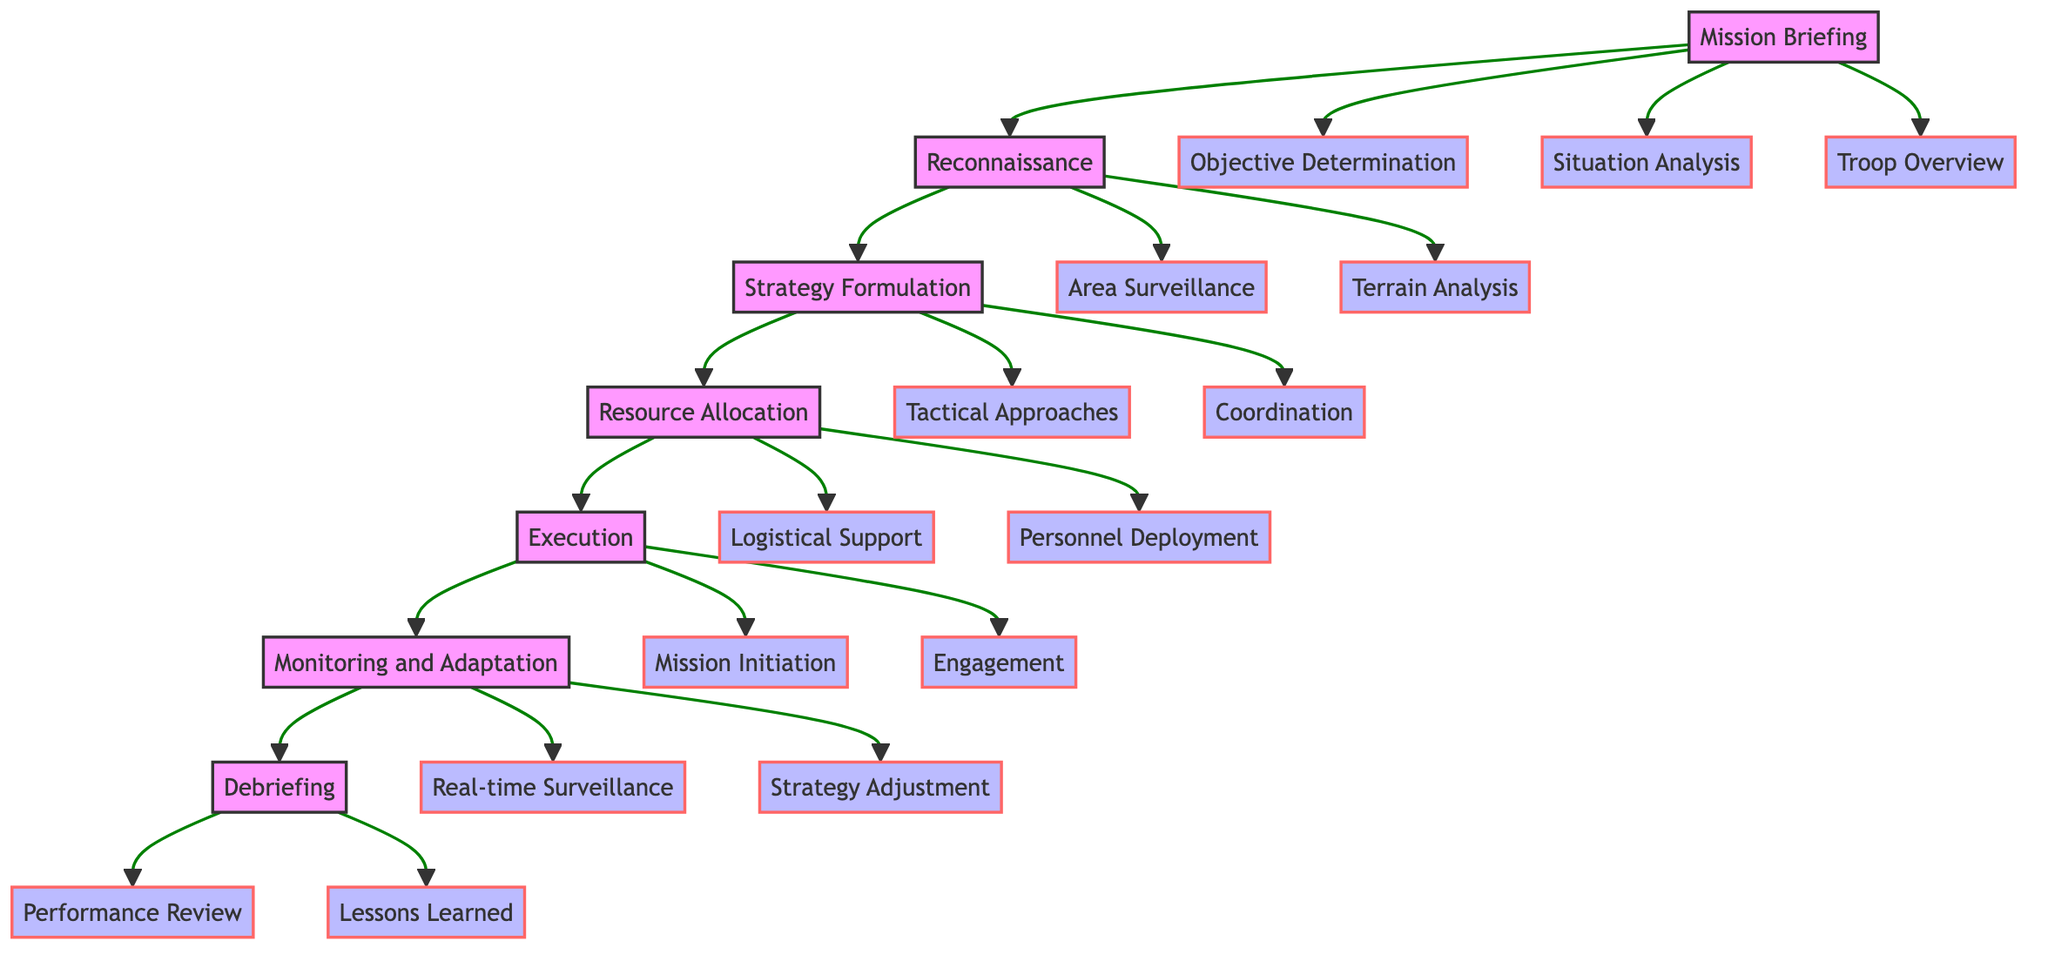What is the first step in the military operation planning process? The first step in the flow chart is "Mission Briefing", which outlines the mission objectives and operational environment.
Answer: Mission Briefing How many sub-elements are there under the "Resource Allocation" step? Under "Resource Allocation", there are two sub-elements: "Logistical Support" and "Personnel Deployment".
Answer: 2 What follows the "Execution" step in the diagram? "Monitoring and Adaptation" directly follows the "Execution" step as the next stage in the process.
Answer: Monitoring and Adaptation Which step involves gathering intelligence about enemy forces? The step that involves gathering intelligence about enemy forces is "Situation Analysis", which is a sub-element of "Mission Briefing".
Answer: Situation Analysis What type of support is planned during the "Resource Allocation" step? "Logistical Support" is planned during the "Resource Allocation" step to ensure the mission has necessary supplies.
Answer: Logistical Support What is the last step of the military operation planning process? The last step in the flow chart is "Debriefing", which focuses on post-mission analysis and reporting.
Answer: Debriefing What are the two sub-elements under "Execution"? The two sub-elements under "Execution" are "Mission Initiation" and "Engagement".
Answer: Mission Initiation and Engagement Which step includes the "Coordination" sub-element? "Coordination" is a sub-element of the "Strategy Formulation" step, which involves working with allied units.
Answer: Strategy Formulation In what step is "Real-time Surveillance" used? "Real-time Surveillance" is used in the "Monitoring and Adaptation" step to track the operation as it unfolds.
Answer: Monitoring and Adaptation 